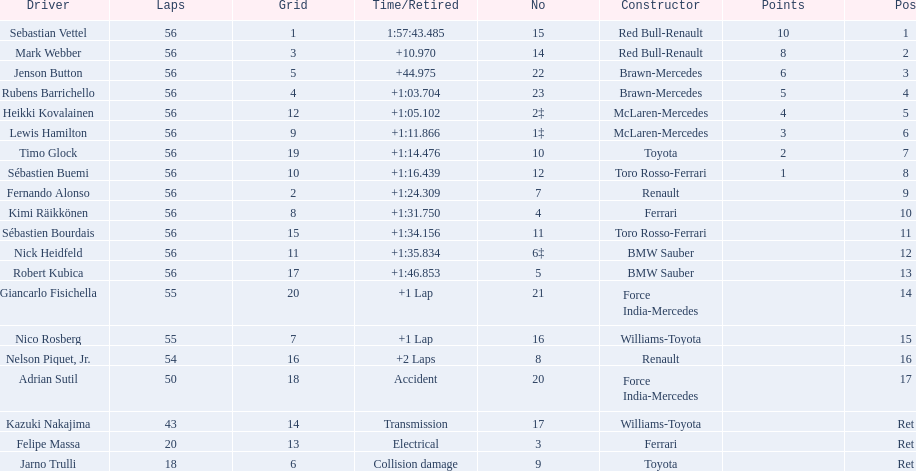Which drivers raced in the 2009 chinese grand prix? Sebastian Vettel, Mark Webber, Jenson Button, Rubens Barrichello, Heikki Kovalainen, Lewis Hamilton, Timo Glock, Sébastien Buemi, Fernando Alonso, Kimi Räikkönen, Sébastien Bourdais, Nick Heidfeld, Robert Kubica, Giancarlo Fisichella, Nico Rosberg, Nelson Piquet, Jr., Adrian Sutil, Kazuki Nakajima, Felipe Massa, Jarno Trulli. Of the drivers in the 2009 chinese grand prix, which finished the race? Sebastian Vettel, Mark Webber, Jenson Button, Rubens Barrichello, Heikki Kovalainen, Lewis Hamilton, Timo Glock, Sébastien Buemi, Fernando Alonso, Kimi Räikkönen, Sébastien Bourdais, Nick Heidfeld, Robert Kubica. Of the drivers who finished the race, who had the slowest time? Robert Kubica. 